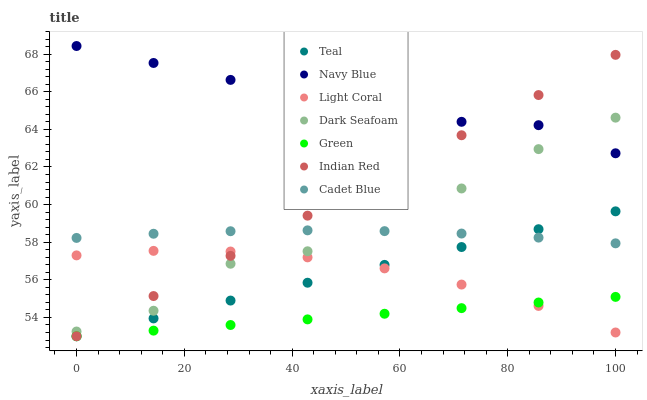Does Green have the minimum area under the curve?
Answer yes or no. Yes. Does Navy Blue have the maximum area under the curve?
Answer yes or no. Yes. Does Teal have the minimum area under the curve?
Answer yes or no. No. Does Teal have the maximum area under the curve?
Answer yes or no. No. Is Teal the smoothest?
Answer yes or no. Yes. Is Dark Seafoam the roughest?
Answer yes or no. Yes. Is Navy Blue the smoothest?
Answer yes or no. No. Is Navy Blue the roughest?
Answer yes or no. No. Does Teal have the lowest value?
Answer yes or no. Yes. Does Navy Blue have the lowest value?
Answer yes or no. No. Does Navy Blue have the highest value?
Answer yes or no. Yes. Does Teal have the highest value?
Answer yes or no. No. Is Green less than Cadet Blue?
Answer yes or no. Yes. Is Cadet Blue greater than Green?
Answer yes or no. Yes. Does Cadet Blue intersect Dark Seafoam?
Answer yes or no. Yes. Is Cadet Blue less than Dark Seafoam?
Answer yes or no. No. Is Cadet Blue greater than Dark Seafoam?
Answer yes or no. No. Does Green intersect Cadet Blue?
Answer yes or no. No. 